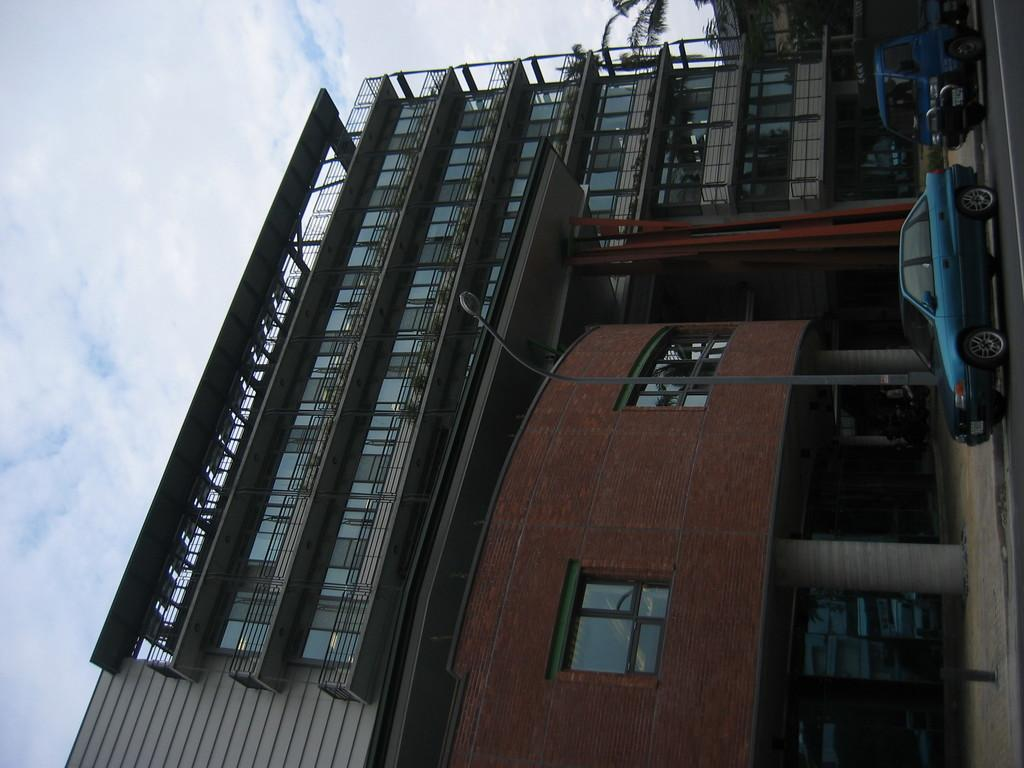What types of objects are in the foreground of the image? There are vehicles, a tree, and a building in the foreground of the image. Can you describe the sky in the background of the image? The sky is visible in the background of the image. How many giraffes can be seen climbing the mountain in the image? There are no giraffes or mountains present in the image. What type of hammer is being used to construct the building in the image? There is no hammer visible in the image, and the building is already constructed. 